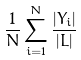Convert formula to latex. <formula><loc_0><loc_0><loc_500><loc_500>\frac { 1 } { N } \sum _ { i = 1 } ^ { N } \frac { | Y _ { i } | } { | L | }</formula> 